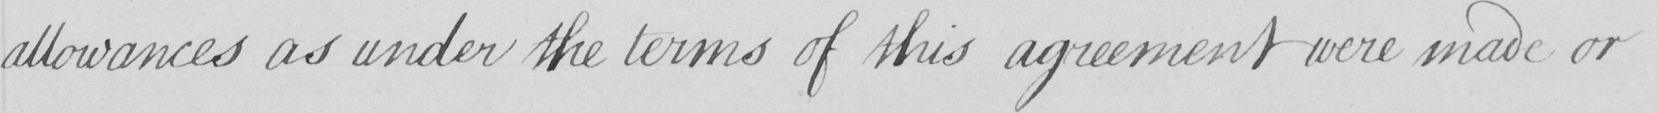Please transcribe the handwritten text in this image. allowances as under the terms of this agreement were made or 